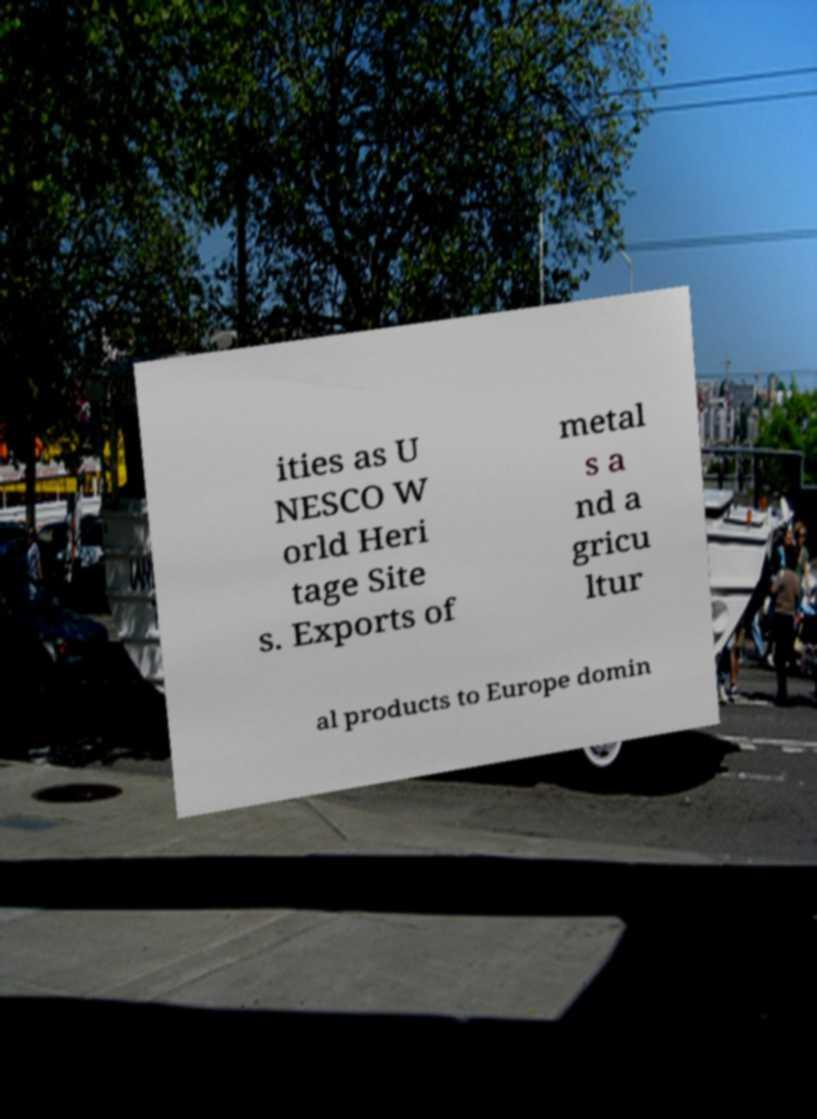There's text embedded in this image that I need extracted. Can you transcribe it verbatim? ities as U NESCO W orld Heri tage Site s. Exports of metal s a nd a gricu ltur al products to Europe domin 